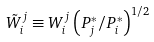Convert formula to latex. <formula><loc_0><loc_0><loc_500><loc_500>\tilde { W } _ { i } ^ { j } \equiv W _ { i } ^ { j } \left ( P _ { j } ^ { * } / P _ { i } ^ { * } \right ) ^ { 1 / 2 }</formula> 